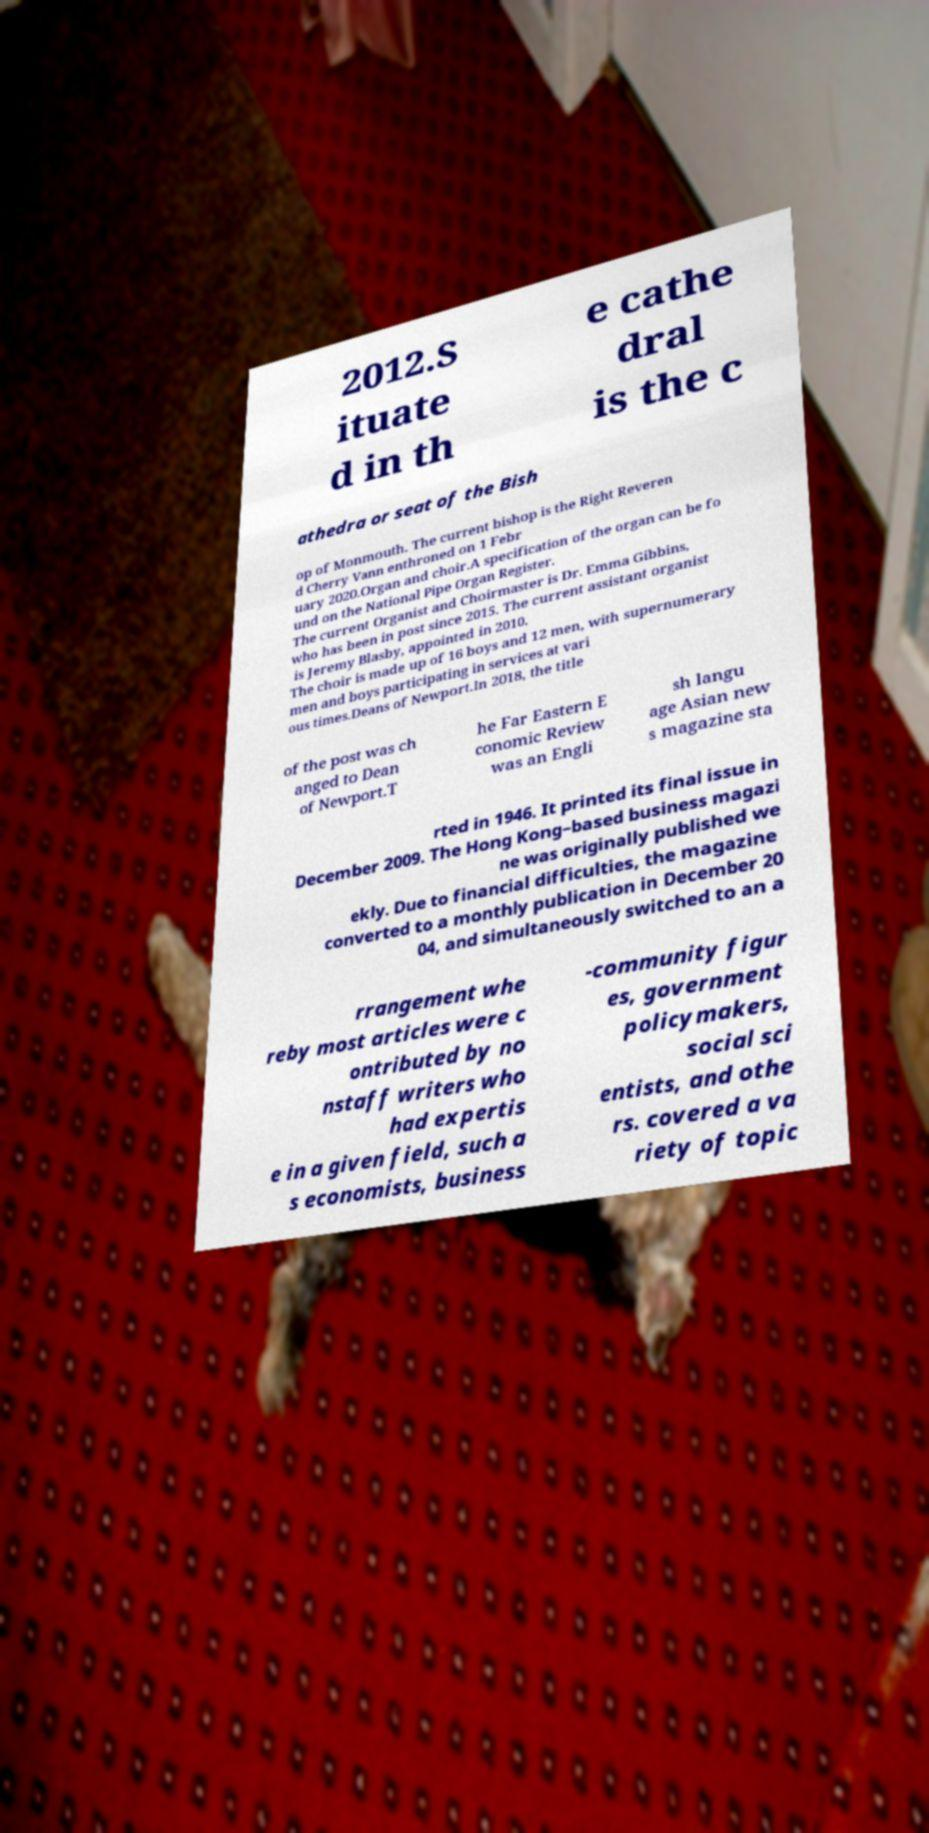Please read and relay the text visible in this image. What does it say? 2012.S ituate d in th e cathe dral is the c athedra or seat of the Bish op of Monmouth. The current bishop is the Right Reveren d Cherry Vann enthroned on 1 Febr uary 2020.Organ and choir.A specification of the organ can be fo und on the National Pipe Organ Register. The current Organist and Choirmaster is Dr. Emma Gibbins, who has been in post since 2015. The current assistant organist is Jeremy Blasby, appointed in 2010. The choir is made up of 16 boys and 12 men, with supernumerary men and boys participating in services at vari ous times.Deans of Newport.In 2018, the title of the post was ch anged to Dean of Newport.T he Far Eastern E conomic Review was an Engli sh langu age Asian new s magazine sta rted in 1946. It printed its final issue in December 2009. The Hong Kong–based business magazi ne was originally published we ekly. Due to financial difficulties, the magazine converted to a monthly publication in December 20 04, and simultaneously switched to an a rrangement whe reby most articles were c ontributed by no nstaff writers who had expertis e in a given field, such a s economists, business -community figur es, government policymakers, social sci entists, and othe rs. covered a va riety of topic 